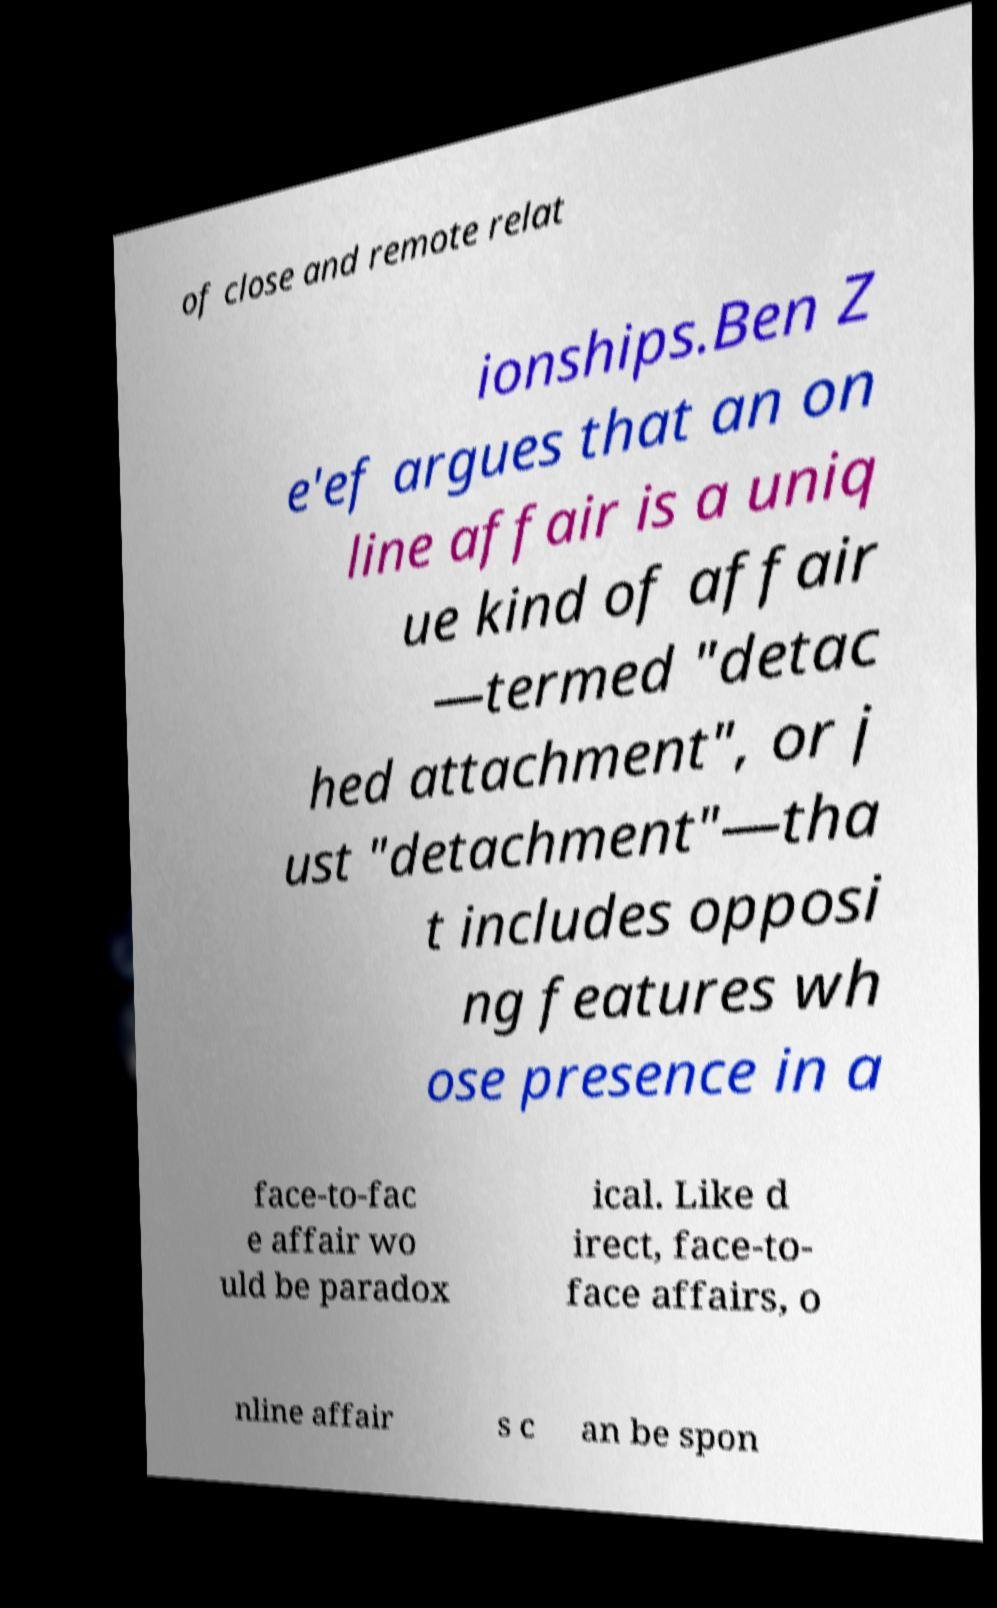Can you accurately transcribe the text from the provided image for me? of close and remote relat ionships.Ben Z e'ef argues that an on line affair is a uniq ue kind of affair —termed "detac hed attachment", or j ust "detachment"—tha t includes opposi ng features wh ose presence in a face-to-fac e affair wo uld be paradox ical. Like d irect, face-to- face affairs, o nline affair s c an be spon 